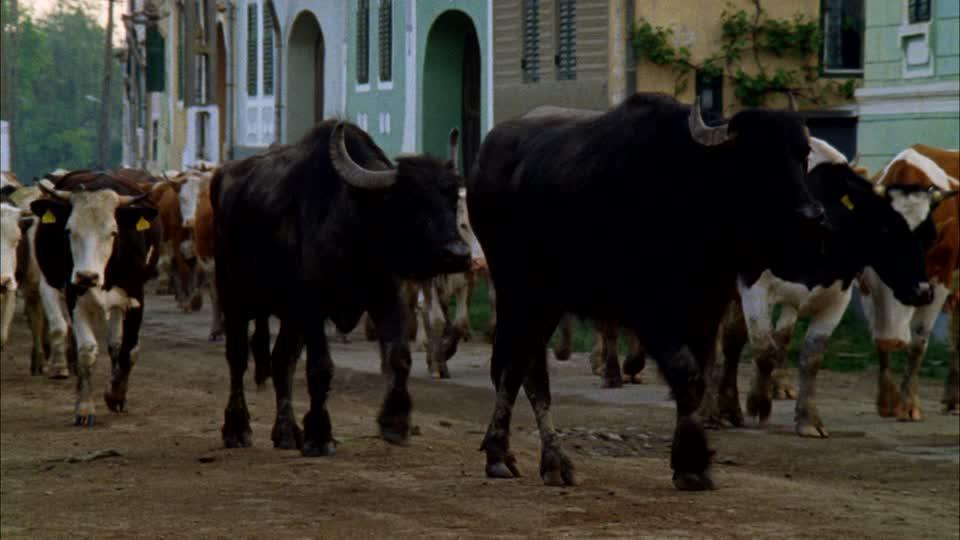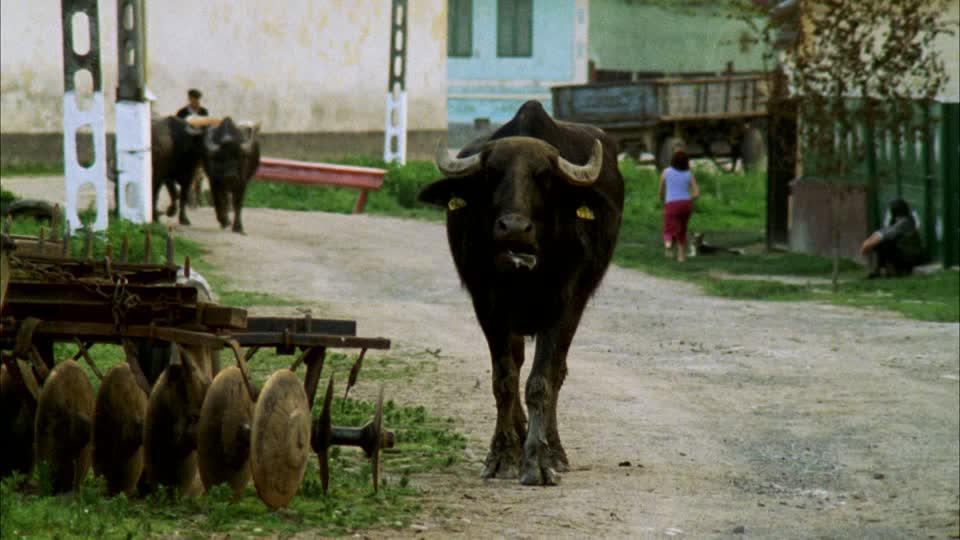The first image is the image on the left, the second image is the image on the right. For the images shown, is this caption "In at least one image, water buffalo are walking rightward down a street lined with buildings." true? Answer yes or no. Yes. The first image is the image on the left, the second image is the image on the right. Assess this claim about the two images: "The right image contains at least one water buffalo walking through a town on a dirt road.". Correct or not? Answer yes or no. Yes. 